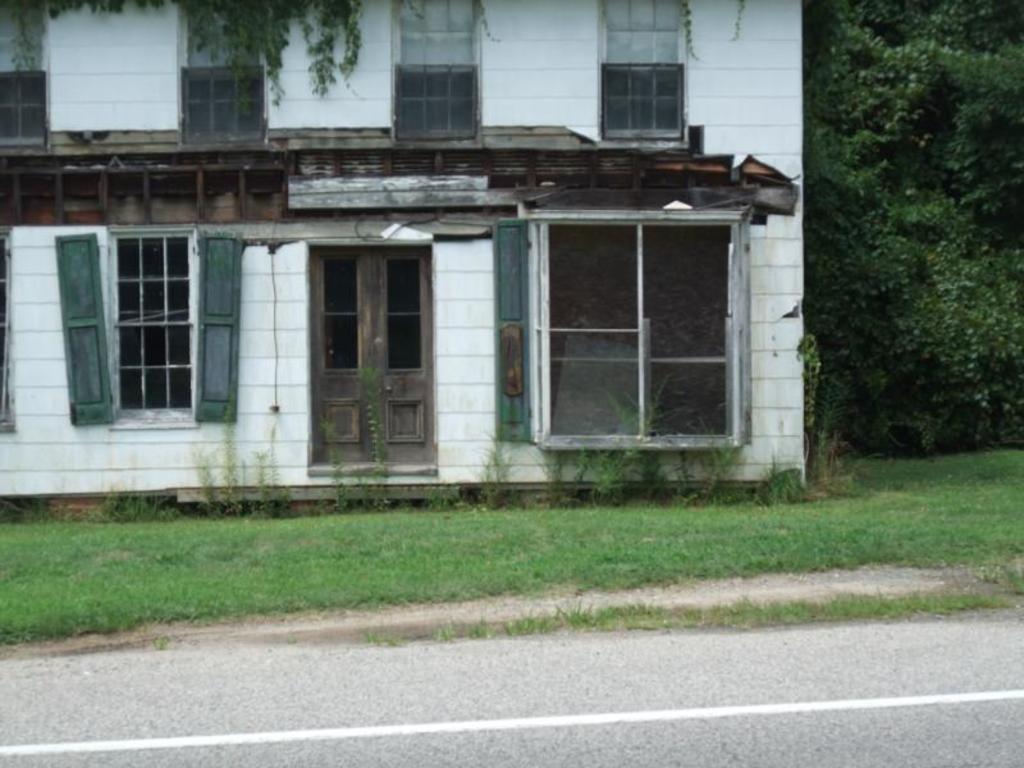Can you describe this image briefly? In this image, I can see a building with a door and windows. In front of the building, I can see the grass and road. On the right side of the image, there are trees. 